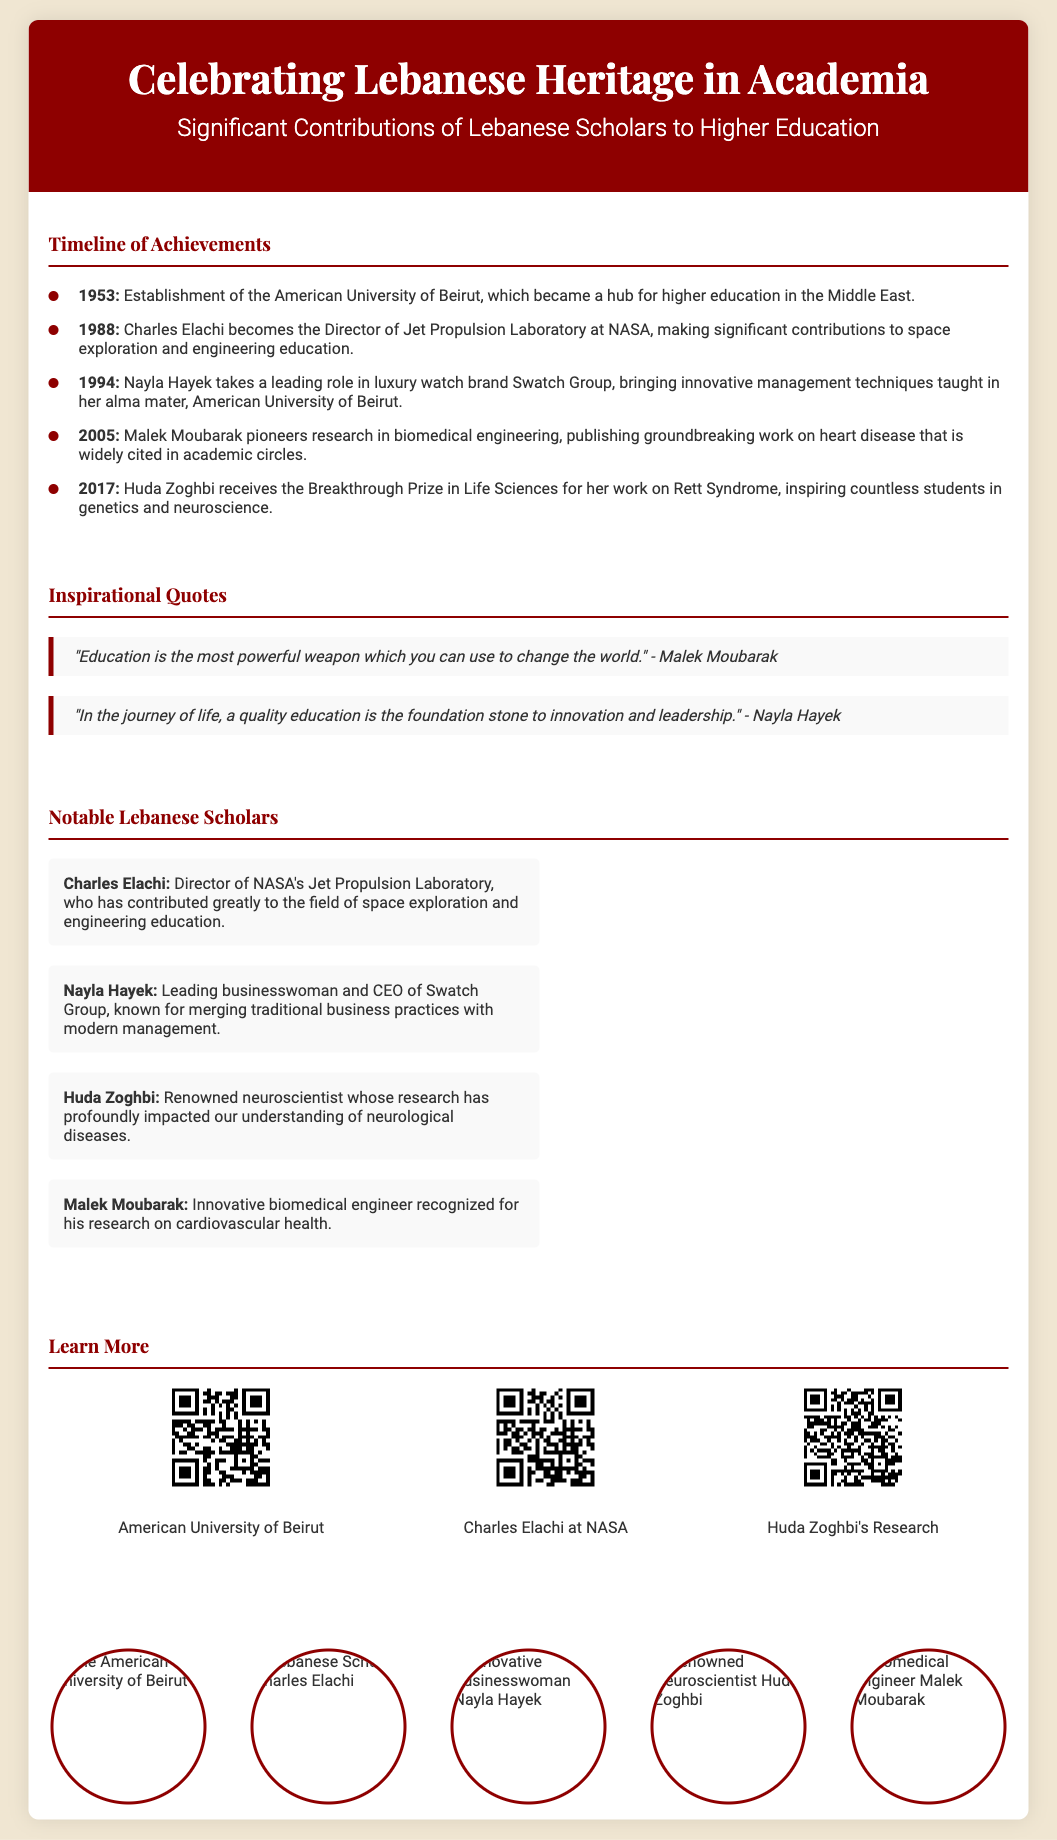what year was the American University of Beirut established? The establishment of the American University of Beirut is mentioned in the timeline as occurring in 1953.
Answer: 1953 who is the Director of NASA's Jet Propulsion Laboratory mentioned in the poster? Charles Elachi is highlighted as the Director of NASA's Jet Propulsion Laboratory in the notable Lebanese scholars section.
Answer: Charles Elachi which Lebanese scholar received the Breakthrough Prize in Life Sciences? Huda Zoghbi is noted for receiving this prize for her research on Rett Syndrome in 2017.
Answer: Huda Zoghbi what significant contribution did Malek Moubarak make in 2005? The timeline describes his pioneering research in biomedical engineering and groundbreaking work on heart disease.
Answer: research in biomedical engineering what is the main theme of the poster? The poster celebrates the contributions of Lebanese scholars to higher education.
Answer: Celebrating Lebanese Heritage in Academia how many notable Lebanese scholars are listed in the poster? There are four notable Lebanese scholars mentioned in the document.
Answer: four what type of content can be accessed through the QR codes on the poster? The QR codes provide links to further information about each associated individual or institution in the document.
Answer: further information who is recognized for merging traditional business practices with modern management techniques? Nayla Hayek is identified in the notable Lebanese scholars section for this achievement.
Answer: Nayla Hayek 